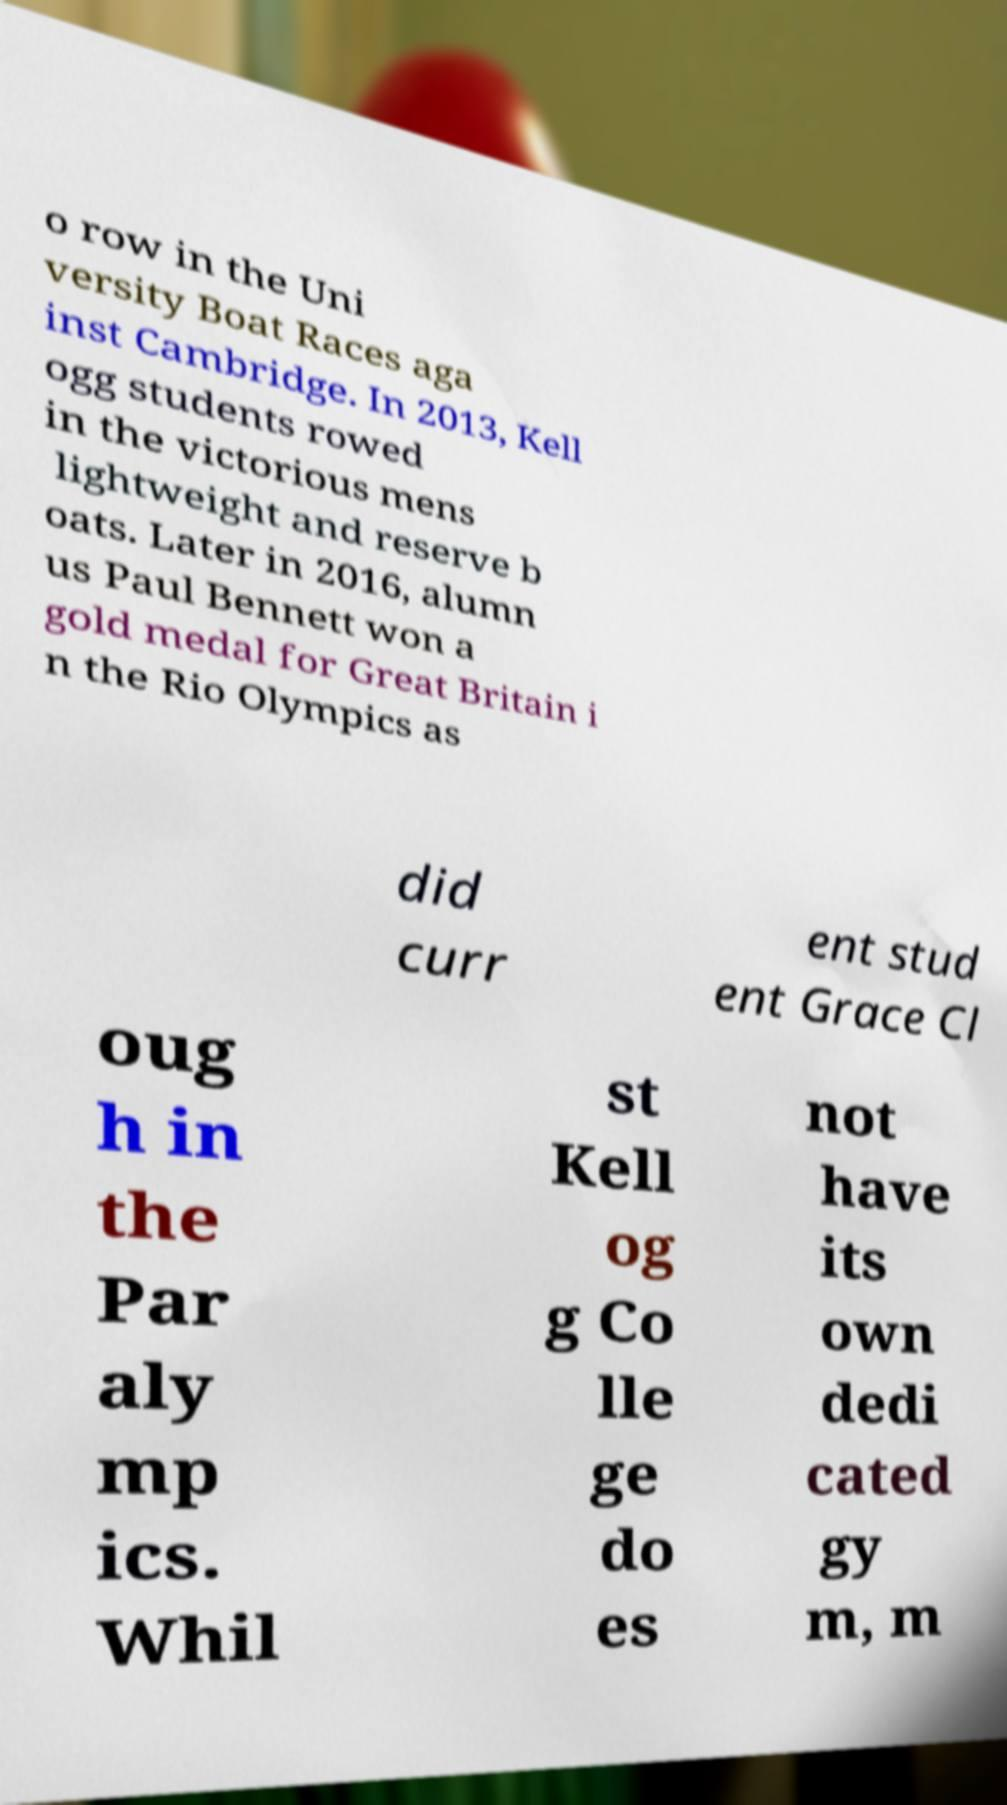What messages or text are displayed in this image? I need them in a readable, typed format. o row in the Uni versity Boat Races aga inst Cambridge. In 2013, Kell ogg students rowed in the victorious mens lightweight and reserve b oats. Later in 2016, alumn us Paul Bennett won a gold medal for Great Britain i n the Rio Olympics as did curr ent stud ent Grace Cl oug h in the Par aly mp ics. Whil st Kell og g Co lle ge do es not have its own dedi cated gy m, m 